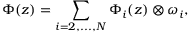<formula> <loc_0><loc_0><loc_500><loc_500>\Phi ( z ) = \sum _ { i = 2 , \dots , N } \Phi _ { i } ( z ) \otimes \omega _ { i } ,</formula> 